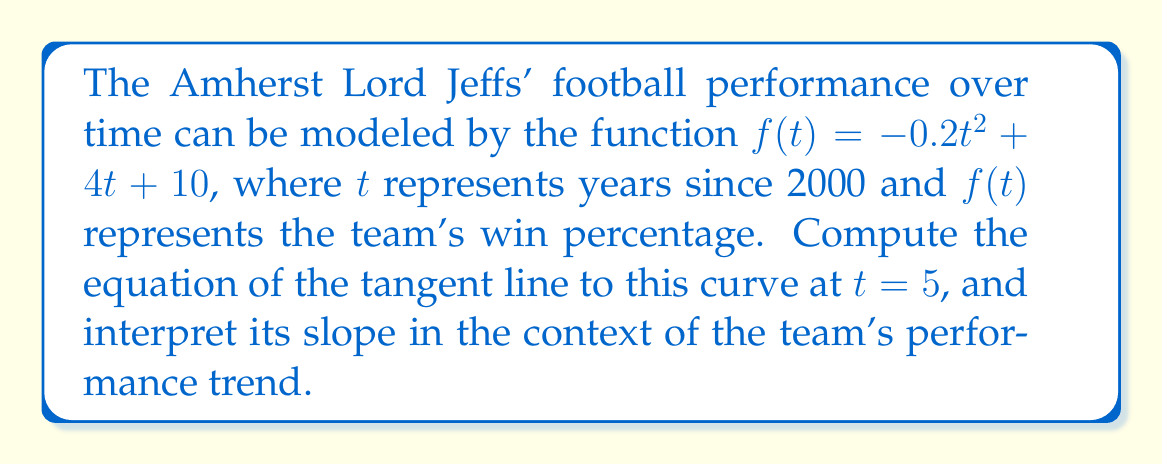Solve this math problem. To find the equation of the tangent line, we need to follow these steps:

1) The general form of a tangent line is $y - y_0 = m(x - x_0)$, where $(x_0, y_0)$ is the point of tangency and $m$ is the slope.

2) To find $y_0$, we evaluate $f(5)$:
   $f(5) = -0.2(5)^2 + 4(5) + 10 = -5 + 20 + 10 = 25$
   So, the point of tangency is $(5, 25)$.

3) To find the slope $m$, we need to calculate $f'(t)$ and then evaluate it at $t=5$:
   $f'(t) = -0.4t + 4$
   $f'(5) = -0.4(5) + 4 = -2 + 4 = 2$

4) Now we have all the components to write the equation of the tangent line:
   $y - 25 = 2(x - 5)$

5) Simplify:
   $y = 2x - 10 + 25$
   $y = 2x + 15$

Interpretation: The slope of 2 indicates that at $t=5$ (year 2005), the Lord Jeffs' win percentage was increasing at a rate of 2% per year. However, since the original function is quadratic with a negative leading coefficient, this rate of increase was at its peak in 2005 and would decrease afterwards, eventually turning negative.
Answer: $y = 2x + 15$ 